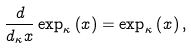<formula> <loc_0><loc_0><loc_500><loc_500>\frac { d } { d _ { \kappa } x } \exp _ { \kappa } \left ( x \right ) = \exp _ { \kappa } \left ( x \right ) ,</formula> 